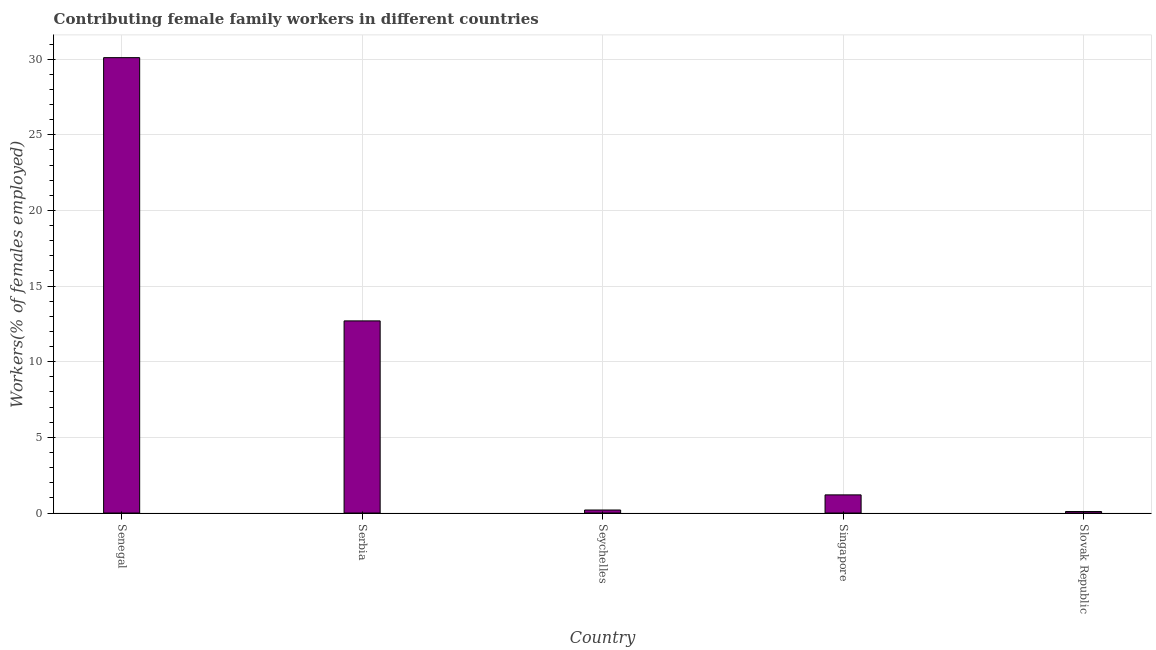Does the graph contain any zero values?
Ensure brevity in your answer.  No. What is the title of the graph?
Offer a terse response. Contributing female family workers in different countries. What is the label or title of the X-axis?
Your answer should be compact. Country. What is the label or title of the Y-axis?
Provide a short and direct response. Workers(% of females employed). What is the contributing female family workers in Seychelles?
Make the answer very short. 0.2. Across all countries, what is the maximum contributing female family workers?
Your answer should be very brief. 30.1. Across all countries, what is the minimum contributing female family workers?
Give a very brief answer. 0.1. In which country was the contributing female family workers maximum?
Give a very brief answer. Senegal. In which country was the contributing female family workers minimum?
Your response must be concise. Slovak Republic. What is the sum of the contributing female family workers?
Make the answer very short. 44.3. What is the difference between the contributing female family workers in Serbia and Singapore?
Provide a succinct answer. 11.5. What is the average contributing female family workers per country?
Ensure brevity in your answer.  8.86. What is the median contributing female family workers?
Your answer should be very brief. 1.2. In how many countries, is the contributing female family workers greater than 12 %?
Your response must be concise. 2. What is the ratio of the contributing female family workers in Serbia to that in Seychelles?
Ensure brevity in your answer.  63.5. What is the difference between the highest and the second highest contributing female family workers?
Your response must be concise. 17.4. In how many countries, is the contributing female family workers greater than the average contributing female family workers taken over all countries?
Keep it short and to the point. 2. What is the difference between two consecutive major ticks on the Y-axis?
Your response must be concise. 5. What is the Workers(% of females employed) in Senegal?
Offer a terse response. 30.1. What is the Workers(% of females employed) in Serbia?
Ensure brevity in your answer.  12.7. What is the Workers(% of females employed) in Seychelles?
Your answer should be compact. 0.2. What is the Workers(% of females employed) in Singapore?
Ensure brevity in your answer.  1.2. What is the Workers(% of females employed) in Slovak Republic?
Give a very brief answer. 0.1. What is the difference between the Workers(% of females employed) in Senegal and Seychelles?
Keep it short and to the point. 29.9. What is the difference between the Workers(% of females employed) in Senegal and Singapore?
Your response must be concise. 28.9. What is the difference between the Workers(% of females employed) in Serbia and Seychelles?
Your answer should be very brief. 12.5. What is the difference between the Workers(% of females employed) in Serbia and Singapore?
Ensure brevity in your answer.  11.5. What is the difference between the Workers(% of females employed) in Seychelles and Singapore?
Give a very brief answer. -1. What is the difference between the Workers(% of females employed) in Seychelles and Slovak Republic?
Make the answer very short. 0.1. What is the difference between the Workers(% of females employed) in Singapore and Slovak Republic?
Provide a succinct answer. 1.1. What is the ratio of the Workers(% of females employed) in Senegal to that in Serbia?
Make the answer very short. 2.37. What is the ratio of the Workers(% of females employed) in Senegal to that in Seychelles?
Your response must be concise. 150.5. What is the ratio of the Workers(% of females employed) in Senegal to that in Singapore?
Provide a short and direct response. 25.08. What is the ratio of the Workers(% of females employed) in Senegal to that in Slovak Republic?
Ensure brevity in your answer.  301. What is the ratio of the Workers(% of females employed) in Serbia to that in Seychelles?
Offer a terse response. 63.5. What is the ratio of the Workers(% of females employed) in Serbia to that in Singapore?
Your response must be concise. 10.58. What is the ratio of the Workers(% of females employed) in Serbia to that in Slovak Republic?
Ensure brevity in your answer.  127. What is the ratio of the Workers(% of females employed) in Seychelles to that in Singapore?
Offer a very short reply. 0.17. What is the ratio of the Workers(% of females employed) in Seychelles to that in Slovak Republic?
Make the answer very short. 2. What is the ratio of the Workers(% of females employed) in Singapore to that in Slovak Republic?
Offer a very short reply. 12. 